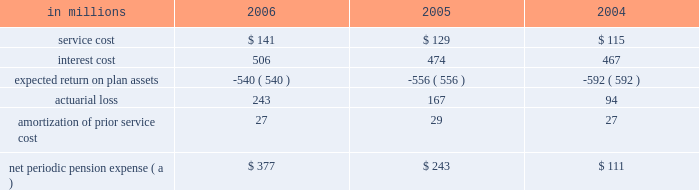Institutions .
International paper continually monitors its positions with and the credit quality of these financial institutions and does not expect non- performance by the counterparties .
Note 14 capital stock the authorized capital stock at both december 31 , 2006 and 2005 , consisted of 990850000 shares of common stock , $ 1 par value ; 400000 shares of cumulative $ 4 preferred stock , without par value ( stated value $ 100 per share ) ; and 8750000 shares of serial preferred stock , $ 1 par value .
The serial preferred stock is issuable in one or more series by the board of directors without further shareholder action .
In july 2006 , in connection with the planned use of projected proceeds from the company 2019s trans- formation plan , international paper 2019s board of direc- tors authorized a share repurchase program to acquire up to $ 3.0 billion of the company 2019s stock .
In a modified 201cdutch auction 201d tender offer completed in september 2006 , international paper purchased 38465260 shares of its common stock at a price of $ 36.00 per share , plus costs to acquire the shares , for a total cost of approximately $ 1.4 billion .
In addition , in december 2006 , the company purchased an addi- tional 1220558 shares of its common stock in the open market at an average price of $ 33.84 per share , plus costs to acquire the shares , for a total cost of approximately $ 41 million .
Following the completion of these share repurchases , international paper had approximately 454 million shares of common stock issued and outstanding .
Note 15 retirement plans u.s .
Defined benefit plans international paper maintains pension plans that provide retirement benefits to substantially all domestic employees hired prior to july 1 , 2004 .
These employees generally are eligible to participate in the plans upon completion of one year of service and attainment of age 21 .
Employees hired after june 30 , 2004 , who are not eligible for these pension plans receive an additional company contribution to their savings plan ( see 201cother plans 201d on page 83 ) .
The plans provide defined benefits based on years of credited service and either final average earnings ( salaried employees ) , hourly job rates or specified benefit rates ( hourly and union employees ) .
For its qualified defined benefit pension plan , interna- tional paper makes contributions that are sufficient to fully fund its actuarially determined costs , gen- erally equal to the minimum amounts required by the employee retirement income security act ( erisa ) .
In addition , international paper made volun- tary contributions of $ 1.0 billion to the qualified defined benefit plan in 2006 , and does not expect to make any contributions in 2007 .
The company also has two unfunded nonqualified defined benefit pension plans : a pension restoration plan available to employees hired prior to july 1 , 2004 that provides retirement benefits based on eligible compensation in excess of limits set by the internal revenue service , and a supplemental retirement plan for senior managers ( serp ) , which is an alternative retirement plan for senior vice presi- dents and above who are designated by the chief executive officer as participants .
These nonqualified plans are only funded to the extent of benefits paid , which are expected to be $ 41 million in 2007 .
Net periodic pension expense service cost is the actuarial present value of benefits attributed by the plans 2019 benefit formula to services rendered by employees during the year .
Interest cost represents the increase in the projected benefit obli- gation , which is a discounted amount , due to the passage of time .
The expected return on plan assets reflects the computed amount of current year earn- ings from the investment of plan assets using an estimated long-term rate of return .
Net periodic pension expense for qualified and nonqualified u.s .
Defined benefit plans comprised the following : in millions 2006 2005 2004 .
( a ) excludes $ 9.1 million , $ 6.5 million and $ 3.4 million in 2006 , 2005 and 2004 , respectively , in curtailment losses , and $ 8.7 million , $ 3.6 million and $ 1.4 million in 2006 , 2005 and 2004 , respectively , of termination benefits , in connection with cost reduction programs and facility rationalizations that were recorded in restructuring and other charges in the con- solidated statement of operations .
Also excludes $ 77.2 million and $ 14.3 million in 2006 and 2005 , respectively , in curtailment losses , and $ 18.6 million and $ 7.6 million of termination bene- fits in 2006 and 2005 , respectively , related to certain divest- itures recorded in net losses on sales and impairments of businesses held for sale in the consolidated statement of oper- ations. .
In 2006 what was the ratio of the curtailment losses to the termination benefits? 
Computations: (14.3 / 18.6)
Answer: 0.76882. 